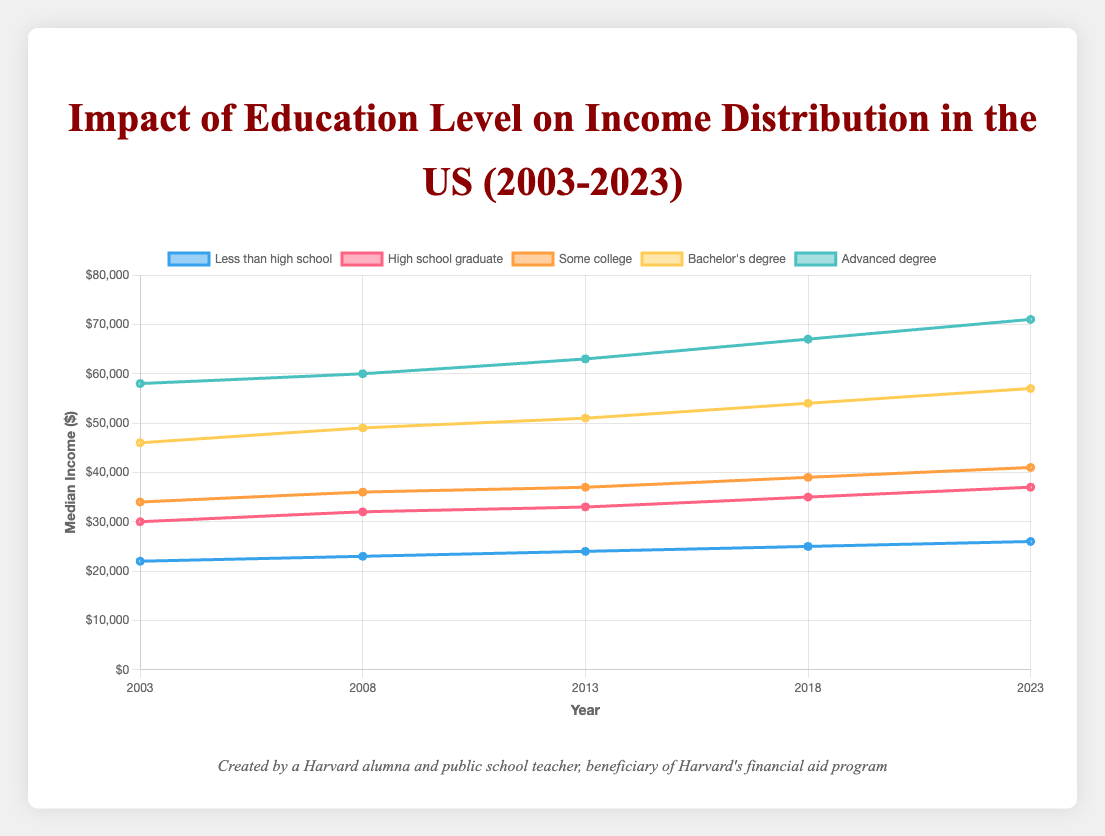Which education level had the highest median income in 2023? The education level with the highest line should be looked at for 2023. The advanced degree line is the highest, indicating $71,000.
Answer: Advanced degree How much did the median income for high school graduates change from 2003 to 2023? Look at the height of the high school graduate line in 2003 and 2023 and calculate the difference. In 2003, it was $30,000, and in 2023, it was $37,000. The change is $37,000 - $30,000 = $7,000.
Answer: $7,000 Did the median income for "Some college" always stay between "High school graduate" and "Bachelor’s degree" over the years? Examine the relative position of the "Some college" line compared to "High school graduate" and "Bachelor's degree" lines across all years. It does consistently fall between the two.
Answer: Yes Which education level saw the largest increase in median income between 2013 and 2023? Calculate the difference in median income for each education level between 2013 and 2023. "Less than high school" ($26,000 - $24,000 = $2,000), "High school graduate" ($37,000 - $33,000 = $4,000), "Some college" ($41,000 - $37,000 = $4,000), "Bachelor's degree" ($57,000 - $51,000 = $6,000), and "Advanced degree" ($71,000 - $63,000 = $8,000). The largest increase is $8,000 for advanced degree.
Answer: Advanced degree What is the overall trend in median income for those with a Bachelor's degree from 2003 to 2023? Observe the pattern of the line for Bachelor’s degree from 2003 to 2023. The line shows a steady increase from $46,000 in 2003 to $57,000 in 2023.
Answer: Increasing In which five-year period did "Some college" level see the smallest growth in median income? Compare the differences in median income for "Some college" across all five-year periods (2003-2008, 2008-2013, 2013-2018, 2018-2023): ($36,000 - $34,000 = $2,000), ($37,000 - $36,000 = $1,000), ($39,000 - $37,000 = $2,000), ($41,000 - $39,000 = $2,000). The smallest growth is $1,000 from 2008 to 2013.
Answer: 2008-2013 Compare the median income trends of "Less than high school" with "Advanced degree." Observe the overall direction and steepness of the lines for both categories. "Less than high school" shows a slower, more modest increase, while "Advanced degree" shows a steeper, more rapid increase in median income.
Answer: "Advanced degree" increases faster What was the median income for "Bachelor's degree" level in 2008, and how does it compare to "Advanced degree" in the same year? Identify the height of the "Bachelor's degree" and "Advanced degree" lines in 2008, which are $49,000 and $60,000 respectively. Compare these values: $49,000 (Bachelor's) < $60,000 (Advanced).
Answer: $49,000, less than "Advanced degree" Which education level had the smallest percentage increase in median income between 2003 and 2023? Calculate the percentage increase for each education level from 2003 to 2023: 
"Less than high school" (26,000 - 22,000) / 22,000 * 100% = 18.18%,
"High school graduate" (37,000 - 30,000) / 30,000 * 100% = 23.33%,
"Some college" (41,000 - 34,000) / 34,000 * 100% = 20.59%,
"Bachelor's degree" (57,000 - 46,000) / 46,000 * 100% = 23.91%,
"Advanced degree" (71,000 - 58,000) / 58,000 * 100% = 22.41%. 
The smallest percentage increase is 18.18% for "Less than high school."
Answer: Less than high school 